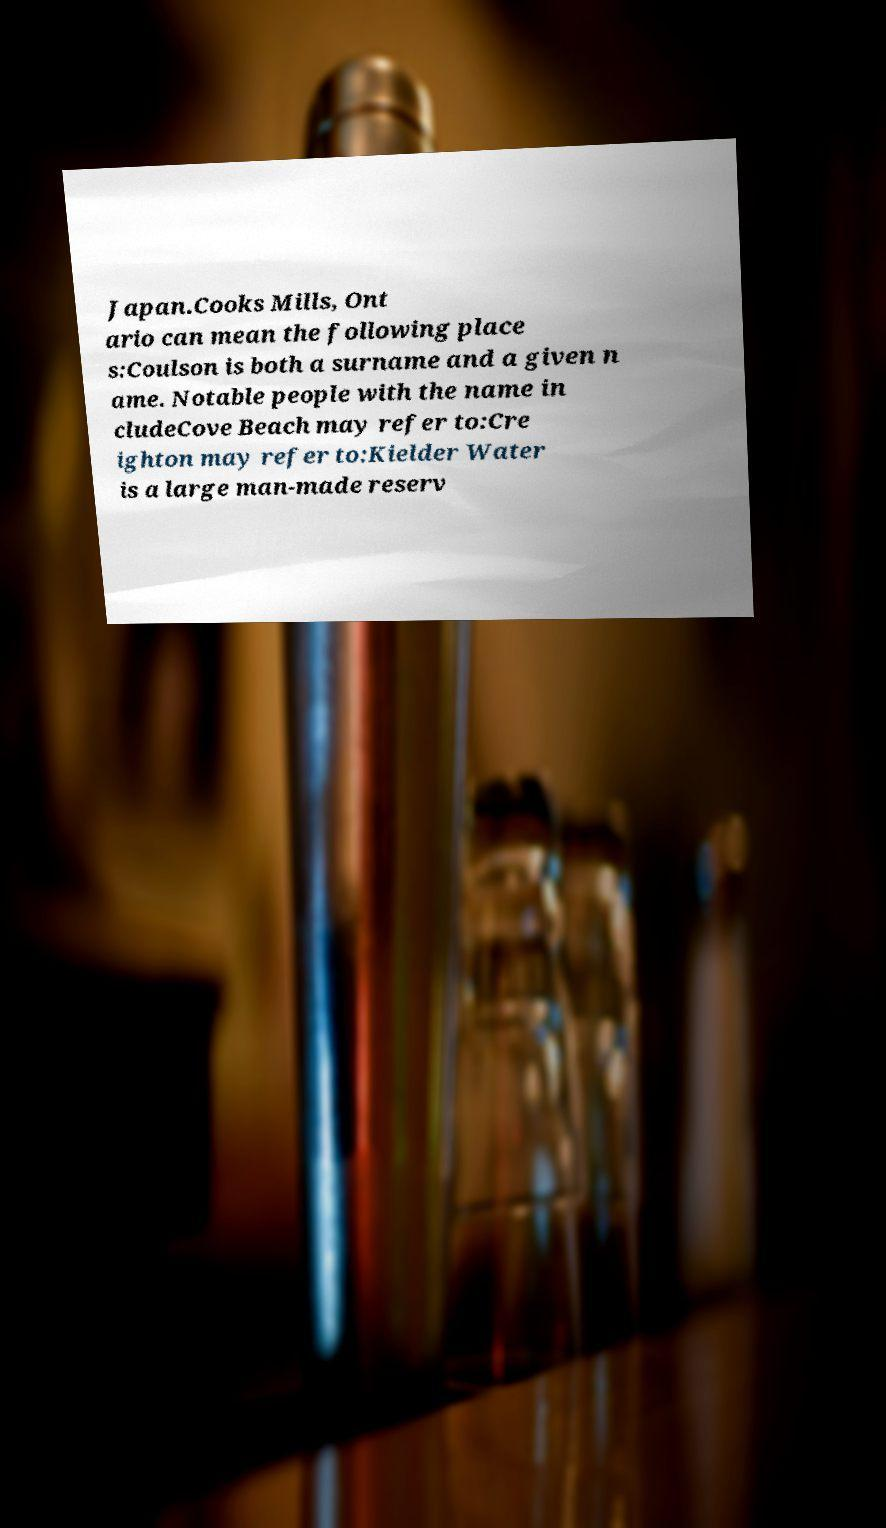Could you extract and type out the text from this image? Japan.Cooks Mills, Ont ario can mean the following place s:Coulson is both a surname and a given n ame. Notable people with the name in cludeCove Beach may refer to:Cre ighton may refer to:Kielder Water is a large man-made reserv 